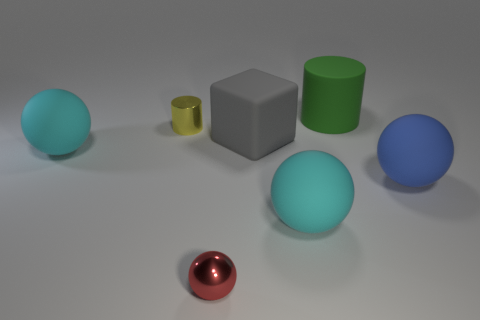Add 1 tiny things. How many objects exist? 8 Subtract all balls. How many objects are left? 3 Add 1 cubes. How many cubes exist? 2 Subtract 2 cyan spheres. How many objects are left? 5 Subtract all tiny blue spheres. Subtract all yellow things. How many objects are left? 6 Add 5 tiny objects. How many tiny objects are left? 7 